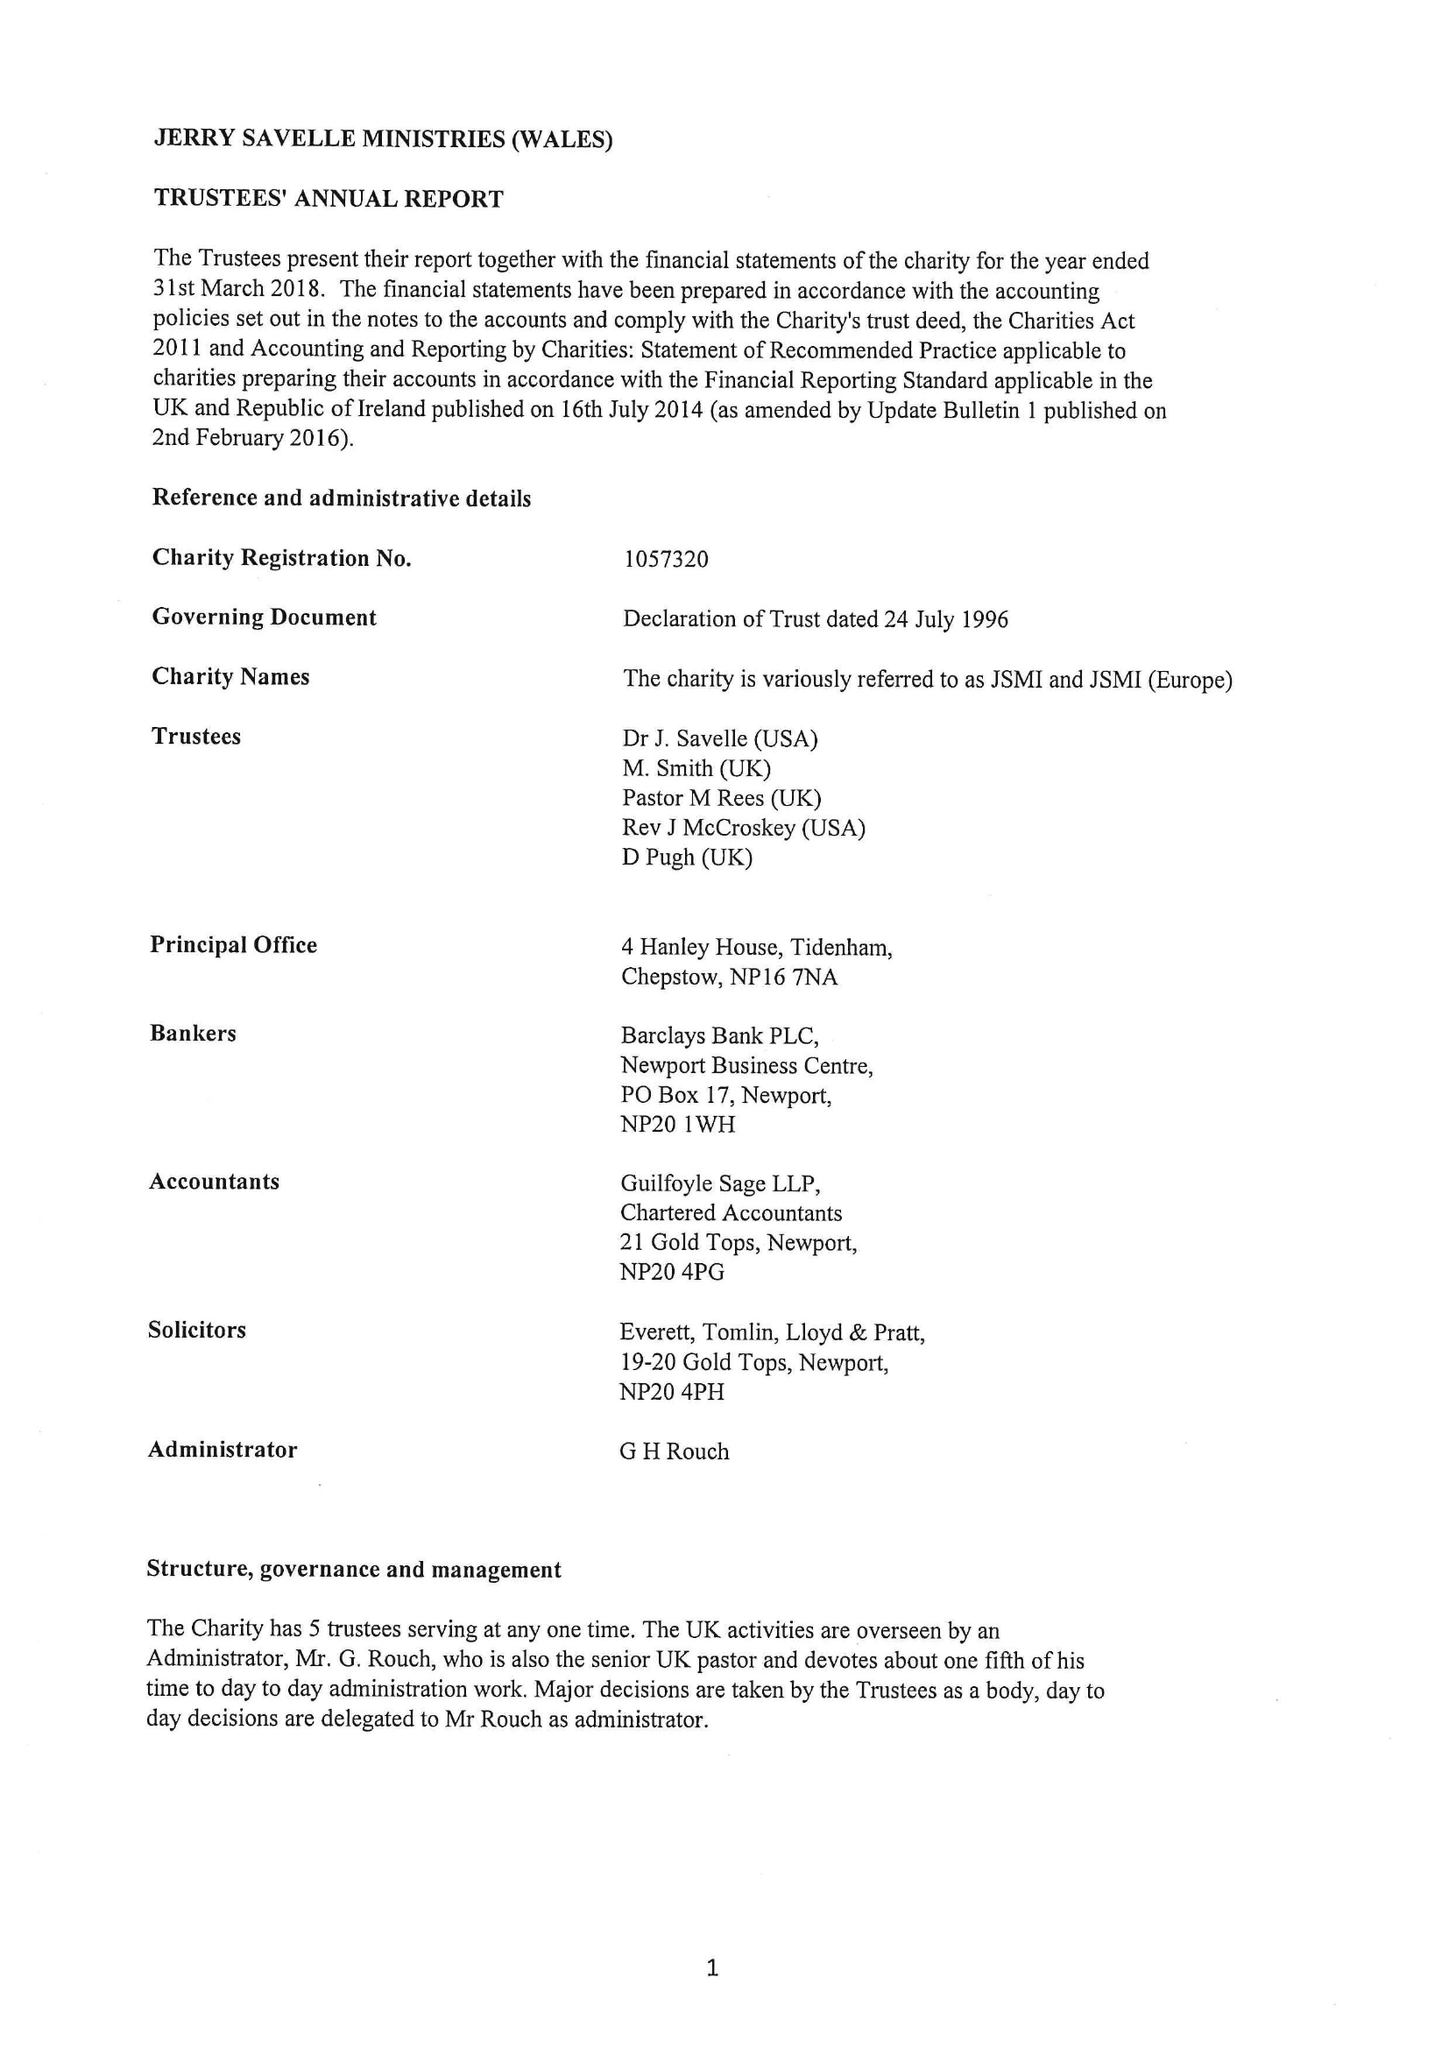What is the value for the report_date?
Answer the question using a single word or phrase. 2018-03-31 